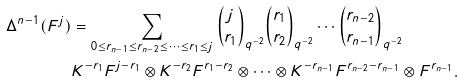<formula> <loc_0><loc_0><loc_500><loc_500>\Delta ^ { n - 1 } ( F ^ { j } ) & = \sum _ { 0 \leq r _ { n - 1 } \leq r _ { n - 2 } \leq \cdots \leq r _ { 1 } \leq j } { j \choose r _ { 1 } } _ { { q ^ { - 2 } } } { r _ { 1 } \choose r _ { 2 } } _ { { q ^ { - 2 } } } \cdots { r _ { n - 2 } \choose r _ { n - 1 } } _ { { q ^ { - 2 } } } \\ & K ^ { - r _ { 1 } } F ^ { j - r _ { 1 } } \otimes K ^ { - r _ { 2 } } F ^ { r _ { 1 } - r _ { 2 } } \otimes \cdots \otimes K ^ { - r _ { n - 1 } } F ^ { r _ { n - 2 } - r _ { n - 1 } } \otimes F ^ { r _ { n - 1 } } .</formula> 